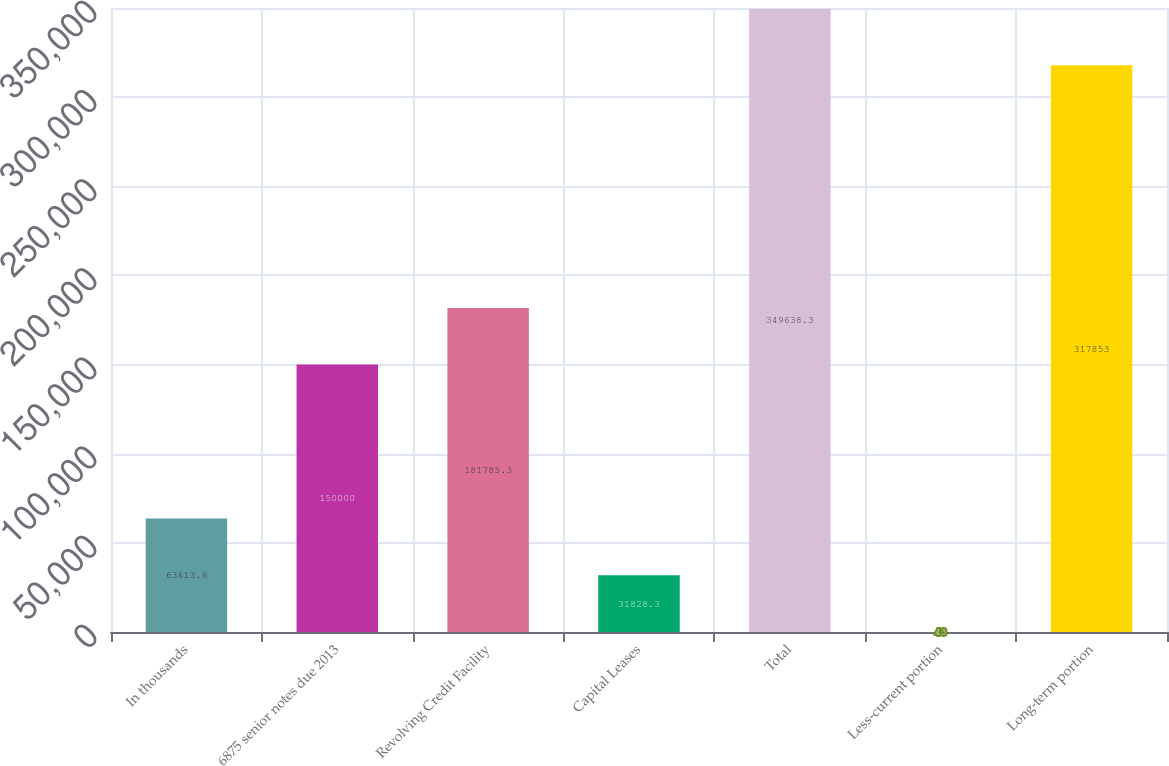Convert chart to OTSL. <chart><loc_0><loc_0><loc_500><loc_500><bar_chart><fcel>In thousands<fcel>6875 senior notes due 2013<fcel>Revolving Credit Facility<fcel>Capital Leases<fcel>Total<fcel>Less-current portion<fcel>Long-term portion<nl><fcel>63613.6<fcel>150000<fcel>181785<fcel>31828.3<fcel>349638<fcel>43<fcel>317853<nl></chart> 